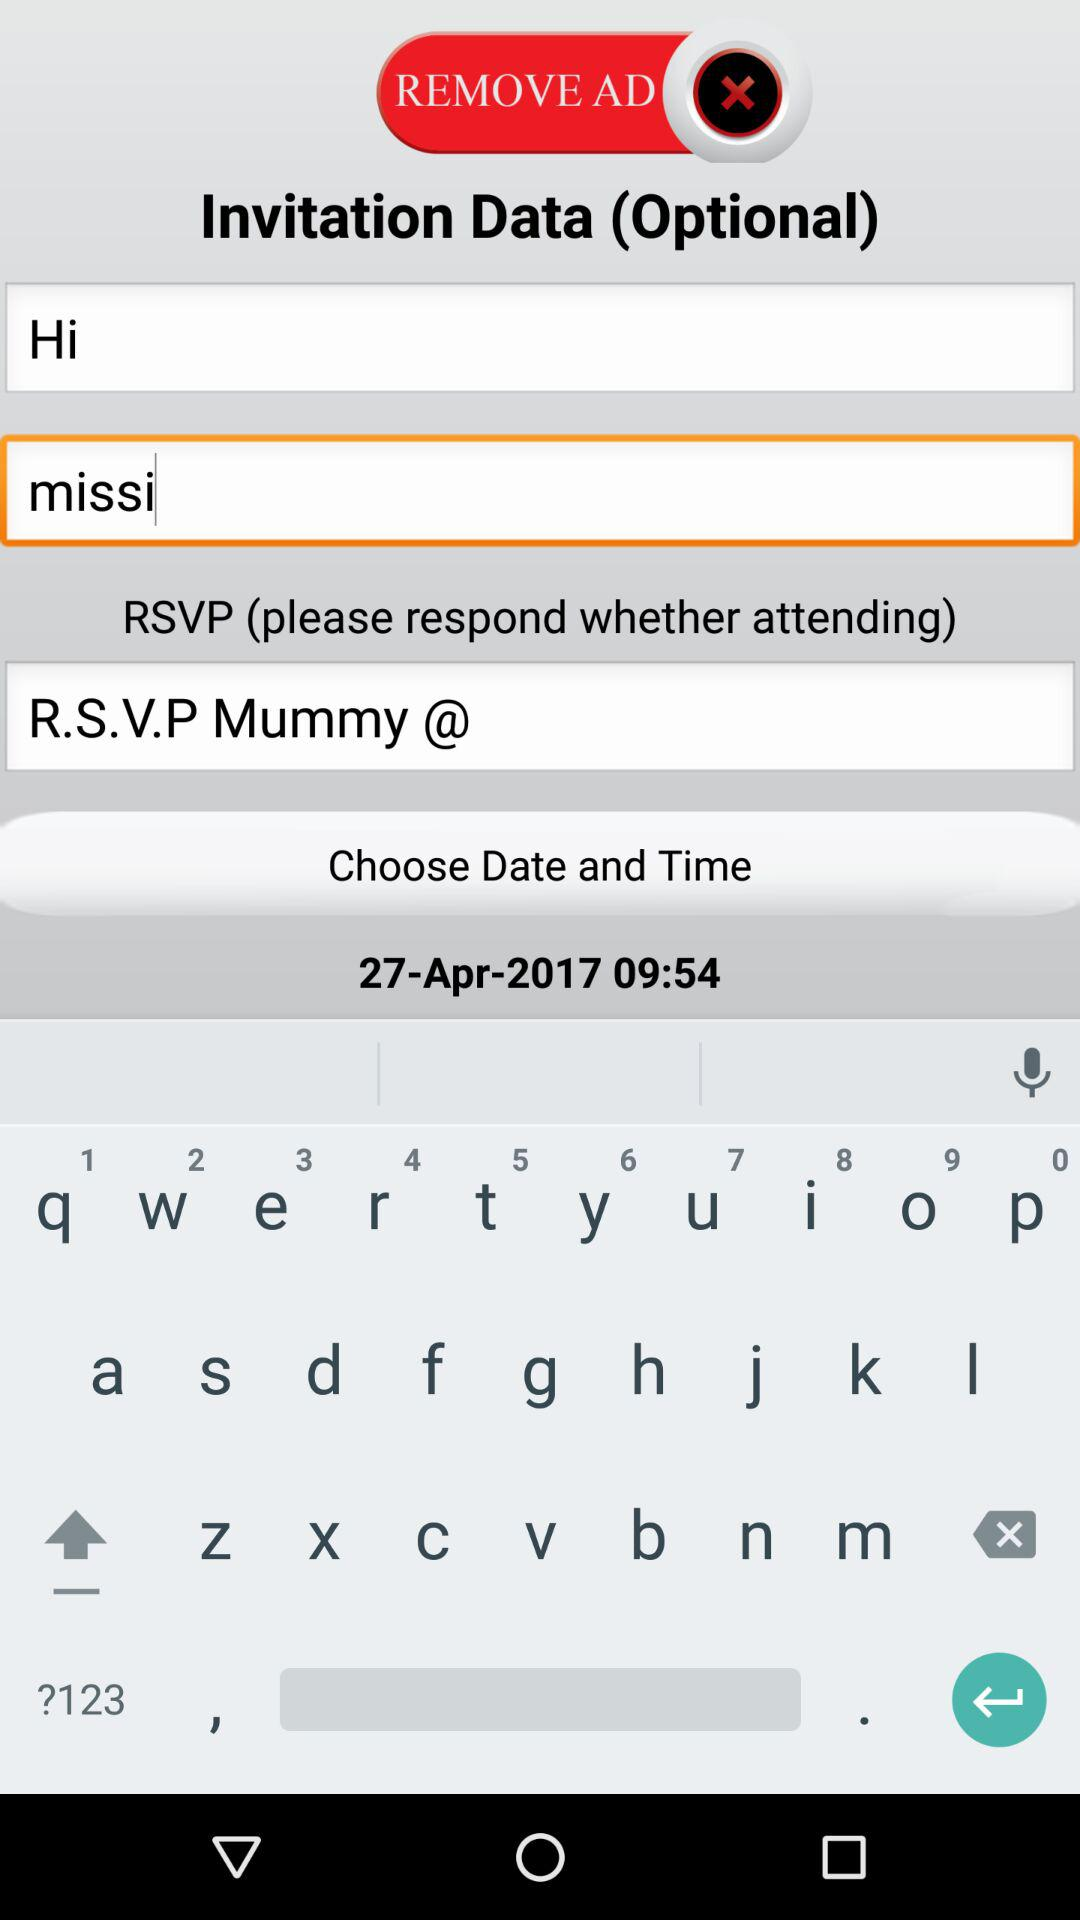How many RSVP text inputs are there on this screen?
Answer the question using a single word or phrase. 1 